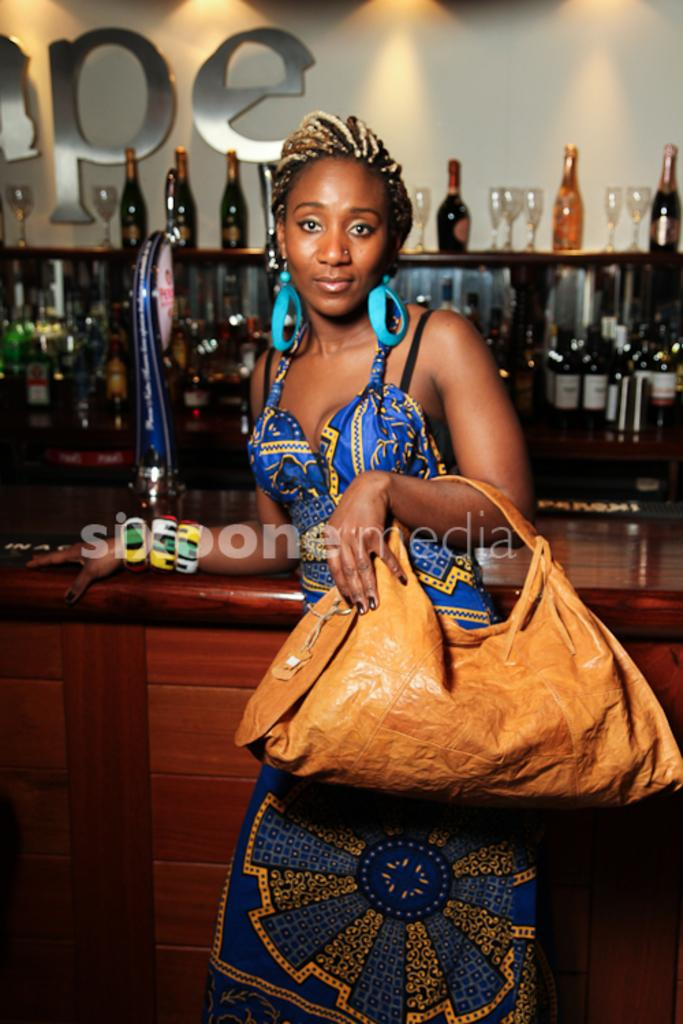Who is present in the image? There is a woman in the image. What is the woman holding in her hand? The woman is carrying a bag in her hand. What is the woman's facial expression? The woman is smiling. What can be seen in the background of the image? There are bottles, glasses, a rack, and a wall in the background of the image. What type of brush is the woman using to clean the shelf in the image? There is no brush or shelf present in the image. 